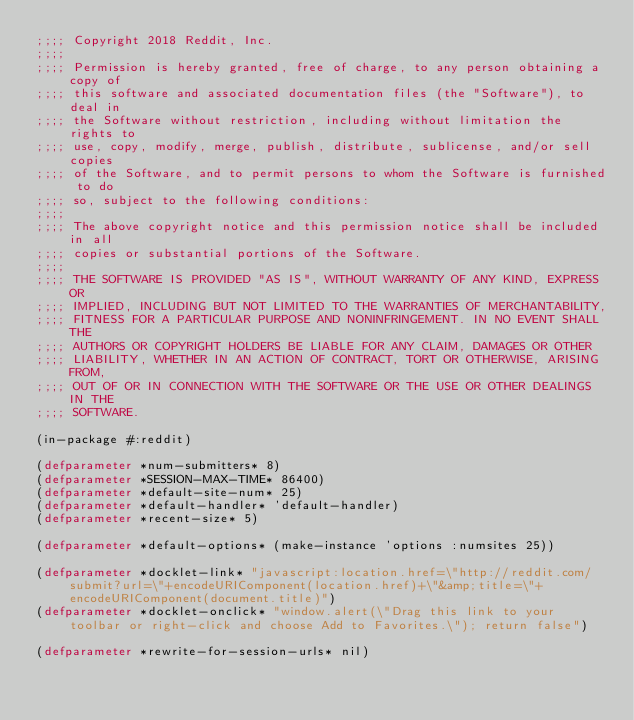Convert code to text. <code><loc_0><loc_0><loc_500><loc_500><_Lisp_>;;;; Copyright 2018 Reddit, Inc.
;;;; 
;;;; Permission is hereby granted, free of charge, to any person obtaining a copy of
;;;; this software and associated documentation files (the "Software"), to deal in
;;;; the Software without restriction, including without limitation the rights to
;;;; use, copy, modify, merge, publish, distribute, sublicense, and/or sell copies
;;;; of the Software, and to permit persons to whom the Software is furnished to do
;;;; so, subject to the following conditions:
;;;; 
;;;; The above copyright notice and this permission notice shall be included in all
;;;; copies or substantial portions of the Software.
;;;; 
;;;; THE SOFTWARE IS PROVIDED "AS IS", WITHOUT WARRANTY OF ANY KIND, EXPRESS OR
;;;; IMPLIED, INCLUDING BUT NOT LIMITED TO THE WARRANTIES OF MERCHANTABILITY,
;;;; FITNESS FOR A PARTICULAR PURPOSE AND NONINFRINGEMENT. IN NO EVENT SHALL THE
;;;; AUTHORS OR COPYRIGHT HOLDERS BE LIABLE FOR ANY CLAIM, DAMAGES OR OTHER
;;;; LIABILITY, WHETHER IN AN ACTION OF CONTRACT, TORT OR OTHERWISE, ARISING FROM,
;;;; OUT OF OR IN CONNECTION WITH THE SOFTWARE OR THE USE OR OTHER DEALINGS IN THE
;;;; SOFTWARE.

(in-package #:reddit)

(defparameter *num-submitters* 8)
(defparameter *SESSION-MAX-TIME* 86400)
(defparameter *default-site-num* 25)
(defparameter *default-handler* 'default-handler)
(defparameter *recent-size* 5)

(defparameter *default-options* (make-instance 'options :numsites 25))

(defparameter *docklet-link* "javascript:location.href=\"http://reddit.com/submit?url=\"+encodeURIComponent(location.href)+\"&amp;title=\"+encodeURIComponent(document.title)")
(defparameter *docklet-onclick* "window.alert(\"Drag this link to your toolbar or right-click and choose Add to Favorites.\"); return false")

(defparameter *rewrite-for-session-urls* nil)
</code> 